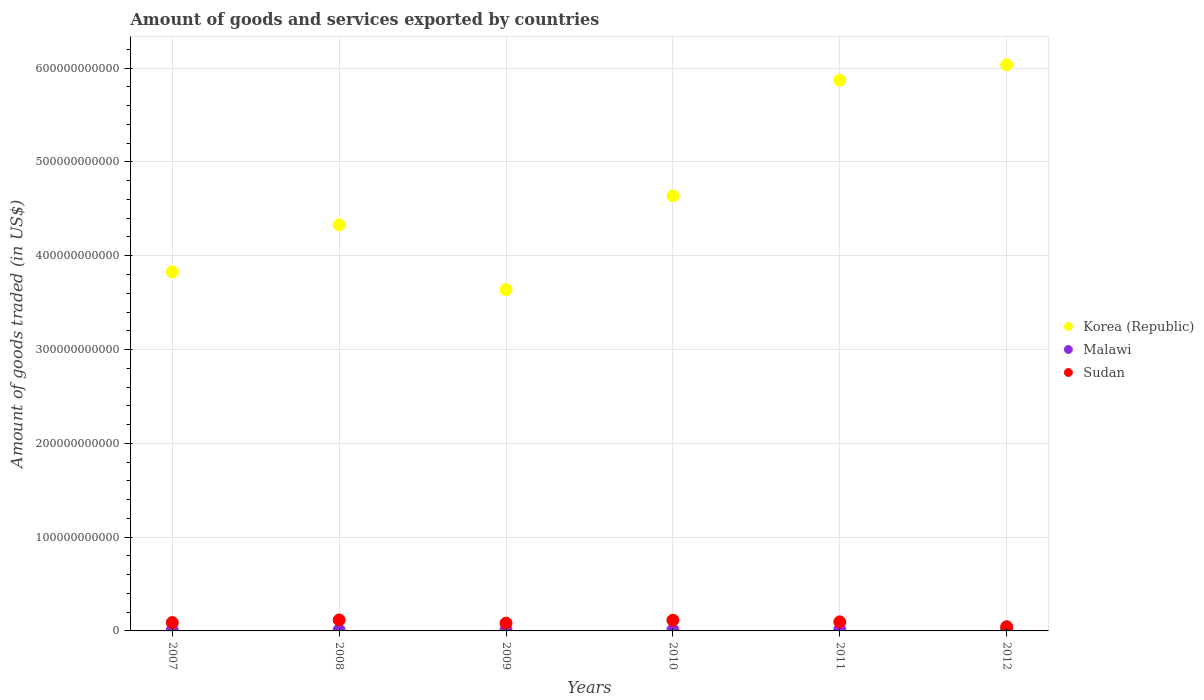How many different coloured dotlines are there?
Your answer should be compact. 3. What is the total amount of goods and services exported in Malawi in 2008?
Ensure brevity in your answer.  9.50e+08. Across all years, what is the maximum total amount of goods and services exported in Korea (Republic)?
Offer a terse response. 6.04e+11. Across all years, what is the minimum total amount of goods and services exported in Sudan?
Provide a short and direct response. 4.48e+09. In which year was the total amount of goods and services exported in Sudan maximum?
Your answer should be compact. 2008. What is the total total amount of goods and services exported in Korea (Republic) in the graph?
Your answer should be very brief. 2.83e+12. What is the difference between the total amount of goods and services exported in Malawi in 2007 and that in 2008?
Offer a very short reply. -1.47e+08. What is the difference between the total amount of goods and services exported in Malawi in 2009 and the total amount of goods and services exported in Sudan in 2010?
Make the answer very short. -1.01e+1. What is the average total amount of goods and services exported in Korea (Republic) per year?
Provide a succinct answer. 4.72e+11. In the year 2010, what is the difference between the total amount of goods and services exported in Malawi and total amount of goods and services exported in Sudan?
Make the answer very short. -1.03e+1. In how many years, is the total amount of goods and services exported in Korea (Republic) greater than 540000000000 US$?
Provide a succinct answer. 2. What is the ratio of the total amount of goods and services exported in Sudan in 2007 to that in 2010?
Ensure brevity in your answer.  0.78. What is the difference between the highest and the second highest total amount of goods and services exported in Korea (Republic)?
Your answer should be very brief. 1.64e+1. What is the difference between the highest and the lowest total amount of goods and services exported in Sudan?
Make the answer very short. 7.19e+09. In how many years, is the total amount of goods and services exported in Korea (Republic) greater than the average total amount of goods and services exported in Korea (Republic) taken over all years?
Provide a short and direct response. 2. Is the total amount of goods and services exported in Sudan strictly less than the total amount of goods and services exported in Korea (Republic) over the years?
Give a very brief answer. Yes. What is the difference between two consecutive major ticks on the Y-axis?
Provide a succinct answer. 1.00e+11. Are the values on the major ticks of Y-axis written in scientific E-notation?
Your response must be concise. No. Does the graph contain any zero values?
Keep it short and to the point. No. Does the graph contain grids?
Give a very brief answer. Yes. What is the title of the graph?
Your answer should be compact. Amount of goods and services exported by countries. Does "Upper middle income" appear as one of the legend labels in the graph?
Offer a terse response. No. What is the label or title of the Y-axis?
Provide a short and direct response. Amount of goods traded (in US$). What is the Amount of goods traded (in US$) in Korea (Republic) in 2007?
Your response must be concise. 3.83e+11. What is the Amount of goods traded (in US$) of Malawi in 2007?
Your answer should be very brief. 8.03e+08. What is the Amount of goods traded (in US$) of Sudan in 2007?
Your answer should be very brief. 8.88e+09. What is the Amount of goods traded (in US$) of Korea (Republic) in 2008?
Keep it short and to the point. 4.33e+11. What is the Amount of goods traded (in US$) in Malawi in 2008?
Your response must be concise. 9.50e+08. What is the Amount of goods traded (in US$) in Sudan in 2008?
Make the answer very short. 1.17e+1. What is the Amount of goods traded (in US$) in Korea (Republic) in 2009?
Keep it short and to the point. 3.64e+11. What is the Amount of goods traded (in US$) in Malawi in 2009?
Your response must be concise. 1.27e+09. What is the Amount of goods traded (in US$) in Sudan in 2009?
Your answer should be compact. 8.26e+09. What is the Amount of goods traded (in US$) of Korea (Republic) in 2010?
Make the answer very short. 4.64e+11. What is the Amount of goods traded (in US$) of Malawi in 2010?
Offer a very short reply. 1.14e+09. What is the Amount of goods traded (in US$) of Sudan in 2010?
Give a very brief answer. 1.14e+1. What is the Amount of goods traded (in US$) in Korea (Republic) in 2011?
Your answer should be very brief. 5.87e+11. What is the Amount of goods traded (in US$) in Malawi in 2011?
Provide a succinct answer. 1.54e+09. What is the Amount of goods traded (in US$) in Sudan in 2011?
Your answer should be compact. 9.66e+09. What is the Amount of goods traded (in US$) of Korea (Republic) in 2012?
Give a very brief answer. 6.04e+11. What is the Amount of goods traded (in US$) in Malawi in 2012?
Offer a very short reply. 1.28e+09. What is the Amount of goods traded (in US$) of Sudan in 2012?
Offer a very short reply. 4.48e+09. Across all years, what is the maximum Amount of goods traded (in US$) of Korea (Republic)?
Provide a succinct answer. 6.04e+11. Across all years, what is the maximum Amount of goods traded (in US$) in Malawi?
Offer a very short reply. 1.54e+09. Across all years, what is the maximum Amount of goods traded (in US$) of Sudan?
Provide a short and direct response. 1.17e+1. Across all years, what is the minimum Amount of goods traded (in US$) of Korea (Republic)?
Make the answer very short. 3.64e+11. Across all years, what is the minimum Amount of goods traded (in US$) of Malawi?
Offer a terse response. 8.03e+08. Across all years, what is the minimum Amount of goods traded (in US$) of Sudan?
Keep it short and to the point. 4.48e+09. What is the total Amount of goods traded (in US$) of Korea (Republic) in the graph?
Your answer should be very brief. 2.83e+12. What is the total Amount of goods traded (in US$) in Malawi in the graph?
Keep it short and to the point. 6.98e+09. What is the total Amount of goods traded (in US$) of Sudan in the graph?
Provide a short and direct response. 5.43e+1. What is the difference between the Amount of goods traded (in US$) of Korea (Republic) in 2007 and that in 2008?
Your response must be concise. -5.01e+1. What is the difference between the Amount of goods traded (in US$) in Malawi in 2007 and that in 2008?
Keep it short and to the point. -1.47e+08. What is the difference between the Amount of goods traded (in US$) in Sudan in 2007 and that in 2008?
Your answer should be very brief. -2.79e+09. What is the difference between the Amount of goods traded (in US$) in Korea (Republic) in 2007 and that in 2009?
Offer a terse response. 1.89e+1. What is the difference between the Amount of goods traded (in US$) of Malawi in 2007 and that in 2009?
Your answer should be compact. -4.65e+08. What is the difference between the Amount of goods traded (in US$) in Sudan in 2007 and that in 2009?
Offer a very short reply. 6.22e+08. What is the difference between the Amount of goods traded (in US$) in Korea (Republic) in 2007 and that in 2010?
Keep it short and to the point. -8.10e+1. What is the difference between the Amount of goods traded (in US$) of Malawi in 2007 and that in 2010?
Your answer should be compact. -3.36e+08. What is the difference between the Amount of goods traded (in US$) of Sudan in 2007 and that in 2010?
Offer a terse response. -2.53e+09. What is the difference between the Amount of goods traded (in US$) of Korea (Republic) in 2007 and that in 2011?
Give a very brief answer. -2.04e+11. What is the difference between the Amount of goods traded (in US$) of Malawi in 2007 and that in 2011?
Give a very brief answer. -7.36e+08. What is the difference between the Amount of goods traded (in US$) of Sudan in 2007 and that in 2011?
Offer a very short reply. -7.76e+08. What is the difference between the Amount of goods traded (in US$) of Korea (Republic) in 2007 and that in 2012?
Your answer should be very brief. -2.21e+11. What is the difference between the Amount of goods traded (in US$) of Malawi in 2007 and that in 2012?
Ensure brevity in your answer.  -4.81e+08. What is the difference between the Amount of goods traded (in US$) in Sudan in 2007 and that in 2012?
Your answer should be very brief. 4.40e+09. What is the difference between the Amount of goods traded (in US$) of Korea (Republic) in 2008 and that in 2009?
Your response must be concise. 6.90e+1. What is the difference between the Amount of goods traded (in US$) of Malawi in 2008 and that in 2009?
Offer a terse response. -3.18e+08. What is the difference between the Amount of goods traded (in US$) of Sudan in 2008 and that in 2009?
Keep it short and to the point. 3.41e+09. What is the difference between the Amount of goods traded (in US$) of Korea (Republic) in 2008 and that in 2010?
Your answer should be very brief. -3.09e+1. What is the difference between the Amount of goods traded (in US$) in Malawi in 2008 and that in 2010?
Provide a short and direct response. -1.89e+08. What is the difference between the Amount of goods traded (in US$) in Sudan in 2008 and that in 2010?
Your response must be concise. 2.66e+08. What is the difference between the Amount of goods traded (in US$) of Korea (Republic) in 2008 and that in 2011?
Offer a very short reply. -1.54e+11. What is the difference between the Amount of goods traded (in US$) in Malawi in 2008 and that in 2011?
Keep it short and to the point. -5.89e+08. What is the difference between the Amount of goods traded (in US$) of Sudan in 2008 and that in 2011?
Offer a very short reply. 2.01e+09. What is the difference between the Amount of goods traded (in US$) of Korea (Republic) in 2008 and that in 2012?
Ensure brevity in your answer.  -1.71e+11. What is the difference between the Amount of goods traded (in US$) in Malawi in 2008 and that in 2012?
Offer a terse response. -3.35e+08. What is the difference between the Amount of goods traded (in US$) in Sudan in 2008 and that in 2012?
Your answer should be compact. 7.19e+09. What is the difference between the Amount of goods traded (in US$) in Korea (Republic) in 2009 and that in 2010?
Provide a short and direct response. -9.99e+1. What is the difference between the Amount of goods traded (in US$) of Malawi in 2009 and that in 2010?
Your answer should be very brief. 1.29e+08. What is the difference between the Amount of goods traded (in US$) in Sudan in 2009 and that in 2010?
Provide a succinct answer. -3.15e+09. What is the difference between the Amount of goods traded (in US$) of Korea (Republic) in 2009 and that in 2011?
Provide a succinct answer. -2.23e+11. What is the difference between the Amount of goods traded (in US$) of Malawi in 2009 and that in 2011?
Your response must be concise. -2.71e+08. What is the difference between the Amount of goods traded (in US$) in Sudan in 2009 and that in 2011?
Your answer should be compact. -1.40e+09. What is the difference between the Amount of goods traded (in US$) of Korea (Republic) in 2009 and that in 2012?
Give a very brief answer. -2.40e+11. What is the difference between the Amount of goods traded (in US$) in Malawi in 2009 and that in 2012?
Your answer should be compact. -1.63e+07. What is the difference between the Amount of goods traded (in US$) of Sudan in 2009 and that in 2012?
Provide a succinct answer. 3.78e+09. What is the difference between the Amount of goods traded (in US$) of Korea (Republic) in 2010 and that in 2011?
Your answer should be very brief. -1.23e+11. What is the difference between the Amount of goods traded (in US$) of Malawi in 2010 and that in 2011?
Your response must be concise. -4.00e+08. What is the difference between the Amount of goods traded (in US$) in Sudan in 2010 and that in 2011?
Your answer should be very brief. 1.75e+09. What is the difference between the Amount of goods traded (in US$) in Korea (Republic) in 2010 and that in 2012?
Your answer should be very brief. -1.40e+11. What is the difference between the Amount of goods traded (in US$) of Malawi in 2010 and that in 2012?
Ensure brevity in your answer.  -1.45e+08. What is the difference between the Amount of goods traded (in US$) in Sudan in 2010 and that in 2012?
Make the answer very short. 6.93e+09. What is the difference between the Amount of goods traded (in US$) in Korea (Republic) in 2011 and that in 2012?
Offer a terse response. -1.64e+1. What is the difference between the Amount of goods traded (in US$) of Malawi in 2011 and that in 2012?
Your response must be concise. 2.55e+08. What is the difference between the Amount of goods traded (in US$) of Sudan in 2011 and that in 2012?
Ensure brevity in your answer.  5.18e+09. What is the difference between the Amount of goods traded (in US$) of Korea (Republic) in 2007 and the Amount of goods traded (in US$) of Malawi in 2008?
Give a very brief answer. 3.82e+11. What is the difference between the Amount of goods traded (in US$) in Korea (Republic) in 2007 and the Amount of goods traded (in US$) in Sudan in 2008?
Provide a succinct answer. 3.71e+11. What is the difference between the Amount of goods traded (in US$) of Malawi in 2007 and the Amount of goods traded (in US$) of Sudan in 2008?
Offer a very short reply. -1.09e+1. What is the difference between the Amount of goods traded (in US$) in Korea (Republic) in 2007 and the Amount of goods traded (in US$) in Malawi in 2009?
Your answer should be compact. 3.82e+11. What is the difference between the Amount of goods traded (in US$) in Korea (Republic) in 2007 and the Amount of goods traded (in US$) in Sudan in 2009?
Give a very brief answer. 3.75e+11. What is the difference between the Amount of goods traded (in US$) in Malawi in 2007 and the Amount of goods traded (in US$) in Sudan in 2009?
Offer a terse response. -7.45e+09. What is the difference between the Amount of goods traded (in US$) of Korea (Republic) in 2007 and the Amount of goods traded (in US$) of Malawi in 2010?
Your response must be concise. 3.82e+11. What is the difference between the Amount of goods traded (in US$) of Korea (Republic) in 2007 and the Amount of goods traded (in US$) of Sudan in 2010?
Keep it short and to the point. 3.71e+11. What is the difference between the Amount of goods traded (in US$) in Malawi in 2007 and the Amount of goods traded (in US$) in Sudan in 2010?
Give a very brief answer. -1.06e+1. What is the difference between the Amount of goods traded (in US$) of Korea (Republic) in 2007 and the Amount of goods traded (in US$) of Malawi in 2011?
Keep it short and to the point. 3.81e+11. What is the difference between the Amount of goods traded (in US$) in Korea (Republic) in 2007 and the Amount of goods traded (in US$) in Sudan in 2011?
Offer a very short reply. 3.73e+11. What is the difference between the Amount of goods traded (in US$) of Malawi in 2007 and the Amount of goods traded (in US$) of Sudan in 2011?
Offer a terse response. -8.85e+09. What is the difference between the Amount of goods traded (in US$) in Korea (Republic) in 2007 and the Amount of goods traded (in US$) in Malawi in 2012?
Provide a short and direct response. 3.82e+11. What is the difference between the Amount of goods traded (in US$) of Korea (Republic) in 2007 and the Amount of goods traded (in US$) of Sudan in 2012?
Your answer should be compact. 3.78e+11. What is the difference between the Amount of goods traded (in US$) of Malawi in 2007 and the Amount of goods traded (in US$) of Sudan in 2012?
Provide a short and direct response. -3.67e+09. What is the difference between the Amount of goods traded (in US$) of Korea (Republic) in 2008 and the Amount of goods traded (in US$) of Malawi in 2009?
Provide a succinct answer. 4.32e+11. What is the difference between the Amount of goods traded (in US$) in Korea (Republic) in 2008 and the Amount of goods traded (in US$) in Sudan in 2009?
Ensure brevity in your answer.  4.25e+11. What is the difference between the Amount of goods traded (in US$) of Malawi in 2008 and the Amount of goods traded (in US$) of Sudan in 2009?
Keep it short and to the point. -7.31e+09. What is the difference between the Amount of goods traded (in US$) in Korea (Republic) in 2008 and the Amount of goods traded (in US$) in Malawi in 2010?
Keep it short and to the point. 4.32e+11. What is the difference between the Amount of goods traded (in US$) in Korea (Republic) in 2008 and the Amount of goods traded (in US$) in Sudan in 2010?
Provide a short and direct response. 4.21e+11. What is the difference between the Amount of goods traded (in US$) of Malawi in 2008 and the Amount of goods traded (in US$) of Sudan in 2010?
Offer a very short reply. -1.05e+1. What is the difference between the Amount of goods traded (in US$) of Korea (Republic) in 2008 and the Amount of goods traded (in US$) of Malawi in 2011?
Ensure brevity in your answer.  4.31e+11. What is the difference between the Amount of goods traded (in US$) of Korea (Republic) in 2008 and the Amount of goods traded (in US$) of Sudan in 2011?
Provide a short and direct response. 4.23e+11. What is the difference between the Amount of goods traded (in US$) in Malawi in 2008 and the Amount of goods traded (in US$) in Sudan in 2011?
Your response must be concise. -8.71e+09. What is the difference between the Amount of goods traded (in US$) of Korea (Republic) in 2008 and the Amount of goods traded (in US$) of Malawi in 2012?
Provide a succinct answer. 4.32e+11. What is the difference between the Amount of goods traded (in US$) of Korea (Republic) in 2008 and the Amount of goods traded (in US$) of Sudan in 2012?
Provide a short and direct response. 4.28e+11. What is the difference between the Amount of goods traded (in US$) in Malawi in 2008 and the Amount of goods traded (in US$) in Sudan in 2012?
Ensure brevity in your answer.  -3.53e+09. What is the difference between the Amount of goods traded (in US$) of Korea (Republic) in 2009 and the Amount of goods traded (in US$) of Malawi in 2010?
Your answer should be compact. 3.63e+11. What is the difference between the Amount of goods traded (in US$) of Korea (Republic) in 2009 and the Amount of goods traded (in US$) of Sudan in 2010?
Give a very brief answer. 3.52e+11. What is the difference between the Amount of goods traded (in US$) of Malawi in 2009 and the Amount of goods traded (in US$) of Sudan in 2010?
Your answer should be compact. -1.01e+1. What is the difference between the Amount of goods traded (in US$) of Korea (Republic) in 2009 and the Amount of goods traded (in US$) of Malawi in 2011?
Ensure brevity in your answer.  3.62e+11. What is the difference between the Amount of goods traded (in US$) of Korea (Republic) in 2009 and the Amount of goods traded (in US$) of Sudan in 2011?
Your response must be concise. 3.54e+11. What is the difference between the Amount of goods traded (in US$) in Malawi in 2009 and the Amount of goods traded (in US$) in Sudan in 2011?
Keep it short and to the point. -8.39e+09. What is the difference between the Amount of goods traded (in US$) in Korea (Republic) in 2009 and the Amount of goods traded (in US$) in Malawi in 2012?
Your answer should be compact. 3.63e+11. What is the difference between the Amount of goods traded (in US$) in Korea (Republic) in 2009 and the Amount of goods traded (in US$) in Sudan in 2012?
Offer a very short reply. 3.59e+11. What is the difference between the Amount of goods traded (in US$) of Malawi in 2009 and the Amount of goods traded (in US$) of Sudan in 2012?
Provide a short and direct response. -3.21e+09. What is the difference between the Amount of goods traded (in US$) of Korea (Republic) in 2010 and the Amount of goods traded (in US$) of Malawi in 2011?
Your answer should be very brief. 4.62e+11. What is the difference between the Amount of goods traded (in US$) of Korea (Republic) in 2010 and the Amount of goods traded (in US$) of Sudan in 2011?
Your response must be concise. 4.54e+11. What is the difference between the Amount of goods traded (in US$) of Malawi in 2010 and the Amount of goods traded (in US$) of Sudan in 2011?
Make the answer very short. -8.52e+09. What is the difference between the Amount of goods traded (in US$) of Korea (Republic) in 2010 and the Amount of goods traded (in US$) of Malawi in 2012?
Keep it short and to the point. 4.62e+11. What is the difference between the Amount of goods traded (in US$) of Korea (Republic) in 2010 and the Amount of goods traded (in US$) of Sudan in 2012?
Your answer should be very brief. 4.59e+11. What is the difference between the Amount of goods traded (in US$) in Malawi in 2010 and the Amount of goods traded (in US$) in Sudan in 2012?
Keep it short and to the point. -3.34e+09. What is the difference between the Amount of goods traded (in US$) in Korea (Republic) in 2011 and the Amount of goods traded (in US$) in Malawi in 2012?
Provide a short and direct response. 5.86e+11. What is the difference between the Amount of goods traded (in US$) in Korea (Republic) in 2011 and the Amount of goods traded (in US$) in Sudan in 2012?
Your response must be concise. 5.83e+11. What is the difference between the Amount of goods traded (in US$) in Malawi in 2011 and the Amount of goods traded (in US$) in Sudan in 2012?
Offer a terse response. -2.94e+09. What is the average Amount of goods traded (in US$) of Korea (Republic) per year?
Provide a short and direct response. 4.72e+11. What is the average Amount of goods traded (in US$) in Malawi per year?
Make the answer very short. 1.16e+09. What is the average Amount of goods traded (in US$) in Sudan per year?
Your response must be concise. 9.06e+09. In the year 2007, what is the difference between the Amount of goods traded (in US$) in Korea (Republic) and Amount of goods traded (in US$) in Malawi?
Provide a succinct answer. 3.82e+11. In the year 2007, what is the difference between the Amount of goods traded (in US$) in Korea (Republic) and Amount of goods traded (in US$) in Sudan?
Give a very brief answer. 3.74e+11. In the year 2007, what is the difference between the Amount of goods traded (in US$) in Malawi and Amount of goods traded (in US$) in Sudan?
Ensure brevity in your answer.  -8.08e+09. In the year 2008, what is the difference between the Amount of goods traded (in US$) of Korea (Republic) and Amount of goods traded (in US$) of Malawi?
Make the answer very short. 4.32e+11. In the year 2008, what is the difference between the Amount of goods traded (in US$) of Korea (Republic) and Amount of goods traded (in US$) of Sudan?
Give a very brief answer. 4.21e+11. In the year 2008, what is the difference between the Amount of goods traded (in US$) in Malawi and Amount of goods traded (in US$) in Sudan?
Ensure brevity in your answer.  -1.07e+1. In the year 2009, what is the difference between the Amount of goods traded (in US$) of Korea (Republic) and Amount of goods traded (in US$) of Malawi?
Provide a short and direct response. 3.63e+11. In the year 2009, what is the difference between the Amount of goods traded (in US$) in Korea (Republic) and Amount of goods traded (in US$) in Sudan?
Make the answer very short. 3.56e+11. In the year 2009, what is the difference between the Amount of goods traded (in US$) of Malawi and Amount of goods traded (in US$) of Sudan?
Provide a succinct answer. -6.99e+09. In the year 2010, what is the difference between the Amount of goods traded (in US$) in Korea (Republic) and Amount of goods traded (in US$) in Malawi?
Offer a very short reply. 4.63e+11. In the year 2010, what is the difference between the Amount of goods traded (in US$) of Korea (Republic) and Amount of goods traded (in US$) of Sudan?
Make the answer very short. 4.52e+11. In the year 2010, what is the difference between the Amount of goods traded (in US$) in Malawi and Amount of goods traded (in US$) in Sudan?
Ensure brevity in your answer.  -1.03e+1. In the year 2011, what is the difference between the Amount of goods traded (in US$) in Korea (Republic) and Amount of goods traded (in US$) in Malawi?
Provide a succinct answer. 5.86e+11. In the year 2011, what is the difference between the Amount of goods traded (in US$) in Korea (Republic) and Amount of goods traded (in US$) in Sudan?
Provide a succinct answer. 5.77e+11. In the year 2011, what is the difference between the Amount of goods traded (in US$) in Malawi and Amount of goods traded (in US$) in Sudan?
Give a very brief answer. -8.12e+09. In the year 2012, what is the difference between the Amount of goods traded (in US$) in Korea (Republic) and Amount of goods traded (in US$) in Malawi?
Offer a terse response. 6.02e+11. In the year 2012, what is the difference between the Amount of goods traded (in US$) in Korea (Republic) and Amount of goods traded (in US$) in Sudan?
Your answer should be compact. 5.99e+11. In the year 2012, what is the difference between the Amount of goods traded (in US$) in Malawi and Amount of goods traded (in US$) in Sudan?
Ensure brevity in your answer.  -3.19e+09. What is the ratio of the Amount of goods traded (in US$) of Korea (Republic) in 2007 to that in 2008?
Give a very brief answer. 0.88. What is the ratio of the Amount of goods traded (in US$) of Malawi in 2007 to that in 2008?
Provide a short and direct response. 0.85. What is the ratio of the Amount of goods traded (in US$) of Sudan in 2007 to that in 2008?
Your response must be concise. 0.76. What is the ratio of the Amount of goods traded (in US$) of Korea (Republic) in 2007 to that in 2009?
Keep it short and to the point. 1.05. What is the ratio of the Amount of goods traded (in US$) in Malawi in 2007 to that in 2009?
Provide a succinct answer. 0.63. What is the ratio of the Amount of goods traded (in US$) in Sudan in 2007 to that in 2009?
Keep it short and to the point. 1.08. What is the ratio of the Amount of goods traded (in US$) of Korea (Republic) in 2007 to that in 2010?
Offer a terse response. 0.83. What is the ratio of the Amount of goods traded (in US$) in Malawi in 2007 to that in 2010?
Keep it short and to the point. 0.71. What is the ratio of the Amount of goods traded (in US$) in Sudan in 2007 to that in 2010?
Offer a terse response. 0.78. What is the ratio of the Amount of goods traded (in US$) of Korea (Republic) in 2007 to that in 2011?
Provide a short and direct response. 0.65. What is the ratio of the Amount of goods traded (in US$) of Malawi in 2007 to that in 2011?
Offer a terse response. 0.52. What is the ratio of the Amount of goods traded (in US$) in Sudan in 2007 to that in 2011?
Offer a terse response. 0.92. What is the ratio of the Amount of goods traded (in US$) in Korea (Republic) in 2007 to that in 2012?
Your answer should be compact. 0.63. What is the ratio of the Amount of goods traded (in US$) of Malawi in 2007 to that in 2012?
Your answer should be compact. 0.63. What is the ratio of the Amount of goods traded (in US$) of Sudan in 2007 to that in 2012?
Ensure brevity in your answer.  1.98. What is the ratio of the Amount of goods traded (in US$) in Korea (Republic) in 2008 to that in 2009?
Provide a short and direct response. 1.19. What is the ratio of the Amount of goods traded (in US$) in Malawi in 2008 to that in 2009?
Ensure brevity in your answer.  0.75. What is the ratio of the Amount of goods traded (in US$) of Sudan in 2008 to that in 2009?
Give a very brief answer. 1.41. What is the ratio of the Amount of goods traded (in US$) in Korea (Republic) in 2008 to that in 2010?
Provide a succinct answer. 0.93. What is the ratio of the Amount of goods traded (in US$) of Malawi in 2008 to that in 2010?
Offer a terse response. 0.83. What is the ratio of the Amount of goods traded (in US$) of Sudan in 2008 to that in 2010?
Ensure brevity in your answer.  1.02. What is the ratio of the Amount of goods traded (in US$) of Korea (Republic) in 2008 to that in 2011?
Ensure brevity in your answer.  0.74. What is the ratio of the Amount of goods traded (in US$) of Malawi in 2008 to that in 2011?
Your answer should be very brief. 0.62. What is the ratio of the Amount of goods traded (in US$) of Sudan in 2008 to that in 2011?
Give a very brief answer. 1.21. What is the ratio of the Amount of goods traded (in US$) of Korea (Republic) in 2008 to that in 2012?
Keep it short and to the point. 0.72. What is the ratio of the Amount of goods traded (in US$) of Malawi in 2008 to that in 2012?
Offer a very short reply. 0.74. What is the ratio of the Amount of goods traded (in US$) in Sudan in 2008 to that in 2012?
Your answer should be very brief. 2.61. What is the ratio of the Amount of goods traded (in US$) in Korea (Republic) in 2009 to that in 2010?
Keep it short and to the point. 0.78. What is the ratio of the Amount of goods traded (in US$) of Malawi in 2009 to that in 2010?
Your response must be concise. 1.11. What is the ratio of the Amount of goods traded (in US$) in Sudan in 2009 to that in 2010?
Keep it short and to the point. 0.72. What is the ratio of the Amount of goods traded (in US$) in Korea (Republic) in 2009 to that in 2011?
Ensure brevity in your answer.  0.62. What is the ratio of the Amount of goods traded (in US$) in Malawi in 2009 to that in 2011?
Make the answer very short. 0.82. What is the ratio of the Amount of goods traded (in US$) in Sudan in 2009 to that in 2011?
Provide a succinct answer. 0.86. What is the ratio of the Amount of goods traded (in US$) in Korea (Republic) in 2009 to that in 2012?
Ensure brevity in your answer.  0.6. What is the ratio of the Amount of goods traded (in US$) of Malawi in 2009 to that in 2012?
Your response must be concise. 0.99. What is the ratio of the Amount of goods traded (in US$) in Sudan in 2009 to that in 2012?
Provide a short and direct response. 1.84. What is the ratio of the Amount of goods traded (in US$) in Korea (Republic) in 2010 to that in 2011?
Offer a very short reply. 0.79. What is the ratio of the Amount of goods traded (in US$) in Malawi in 2010 to that in 2011?
Make the answer very short. 0.74. What is the ratio of the Amount of goods traded (in US$) of Sudan in 2010 to that in 2011?
Provide a short and direct response. 1.18. What is the ratio of the Amount of goods traded (in US$) in Korea (Republic) in 2010 to that in 2012?
Provide a short and direct response. 0.77. What is the ratio of the Amount of goods traded (in US$) of Malawi in 2010 to that in 2012?
Ensure brevity in your answer.  0.89. What is the ratio of the Amount of goods traded (in US$) of Sudan in 2010 to that in 2012?
Ensure brevity in your answer.  2.55. What is the ratio of the Amount of goods traded (in US$) in Korea (Republic) in 2011 to that in 2012?
Offer a terse response. 0.97. What is the ratio of the Amount of goods traded (in US$) in Malawi in 2011 to that in 2012?
Your answer should be compact. 1.2. What is the ratio of the Amount of goods traded (in US$) in Sudan in 2011 to that in 2012?
Your response must be concise. 2.16. What is the difference between the highest and the second highest Amount of goods traded (in US$) in Korea (Republic)?
Offer a very short reply. 1.64e+1. What is the difference between the highest and the second highest Amount of goods traded (in US$) in Malawi?
Offer a very short reply. 2.55e+08. What is the difference between the highest and the second highest Amount of goods traded (in US$) of Sudan?
Your answer should be compact. 2.66e+08. What is the difference between the highest and the lowest Amount of goods traded (in US$) of Korea (Republic)?
Provide a short and direct response. 2.40e+11. What is the difference between the highest and the lowest Amount of goods traded (in US$) in Malawi?
Give a very brief answer. 7.36e+08. What is the difference between the highest and the lowest Amount of goods traded (in US$) in Sudan?
Provide a succinct answer. 7.19e+09. 